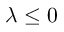Convert formula to latex. <formula><loc_0><loc_0><loc_500><loc_500>\lambda \leq 0</formula> 